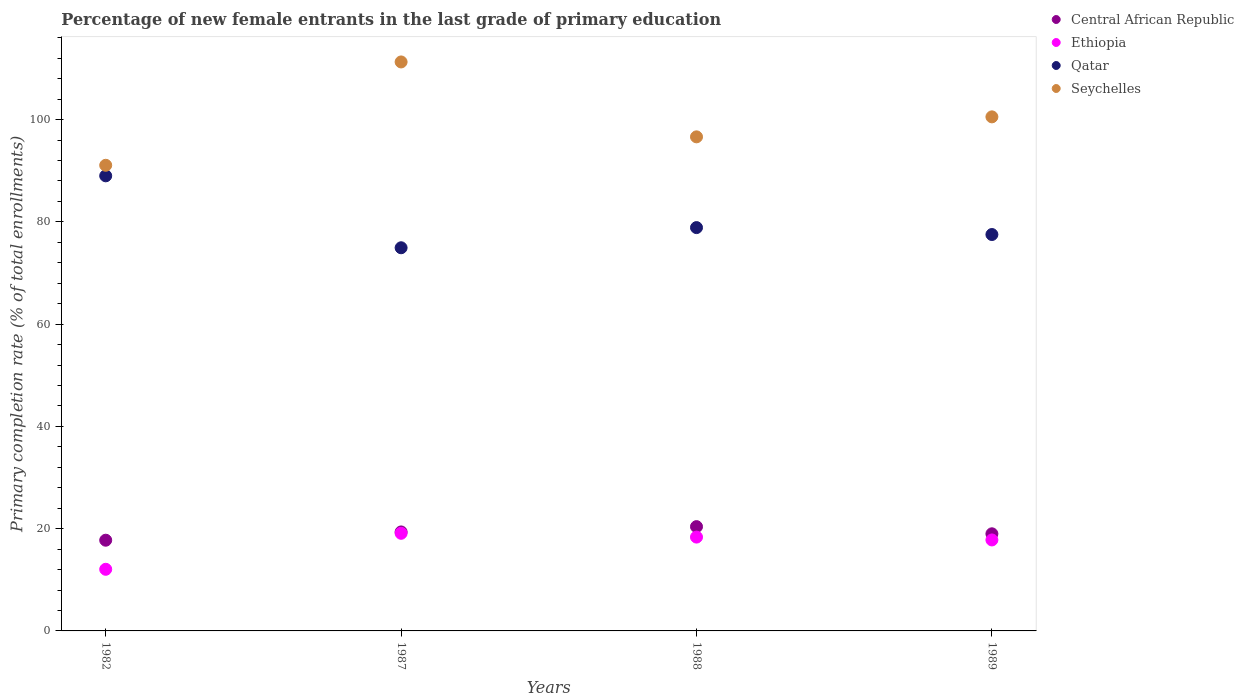How many different coloured dotlines are there?
Give a very brief answer. 4. What is the percentage of new female entrants in Central African Republic in 1988?
Make the answer very short. 20.4. Across all years, what is the maximum percentage of new female entrants in Seychelles?
Provide a succinct answer. 111.28. Across all years, what is the minimum percentage of new female entrants in Seychelles?
Your answer should be compact. 91.06. What is the total percentage of new female entrants in Ethiopia in the graph?
Your answer should be very brief. 67.29. What is the difference between the percentage of new female entrants in Ethiopia in 1987 and that in 1988?
Offer a terse response. 0.74. What is the difference between the percentage of new female entrants in Seychelles in 1982 and the percentage of new female entrants in Qatar in 1987?
Your answer should be very brief. 16.13. What is the average percentage of new female entrants in Qatar per year?
Your response must be concise. 80.08. In the year 1988, what is the difference between the percentage of new female entrants in Seychelles and percentage of new female entrants in Ethiopia?
Offer a very short reply. 78.28. In how many years, is the percentage of new female entrants in Seychelles greater than 8 %?
Give a very brief answer. 4. What is the ratio of the percentage of new female entrants in Ethiopia in 1988 to that in 1989?
Ensure brevity in your answer.  1.03. What is the difference between the highest and the second highest percentage of new female entrants in Central African Republic?
Give a very brief answer. 1.03. What is the difference between the highest and the lowest percentage of new female entrants in Qatar?
Keep it short and to the point. 14.07. In how many years, is the percentage of new female entrants in Seychelles greater than the average percentage of new female entrants in Seychelles taken over all years?
Your answer should be very brief. 2. Is the sum of the percentage of new female entrants in Seychelles in 1982 and 1987 greater than the maximum percentage of new female entrants in Qatar across all years?
Keep it short and to the point. Yes. What is the difference between two consecutive major ticks on the Y-axis?
Make the answer very short. 20. Does the graph contain any zero values?
Provide a succinct answer. No. Does the graph contain grids?
Ensure brevity in your answer.  No. Where does the legend appear in the graph?
Give a very brief answer. Top right. How are the legend labels stacked?
Provide a succinct answer. Vertical. What is the title of the graph?
Ensure brevity in your answer.  Percentage of new female entrants in the last grade of primary education. Does "Turkey" appear as one of the legend labels in the graph?
Keep it short and to the point. No. What is the label or title of the Y-axis?
Provide a short and direct response. Primary completion rate (% of total enrollments). What is the Primary completion rate (% of total enrollments) of Central African Republic in 1982?
Provide a succinct answer. 17.74. What is the Primary completion rate (% of total enrollments) in Ethiopia in 1982?
Your answer should be very brief. 12.05. What is the Primary completion rate (% of total enrollments) in Qatar in 1982?
Your answer should be compact. 89. What is the Primary completion rate (% of total enrollments) in Seychelles in 1982?
Keep it short and to the point. 91.06. What is the Primary completion rate (% of total enrollments) of Central African Republic in 1987?
Provide a short and direct response. 19.36. What is the Primary completion rate (% of total enrollments) in Ethiopia in 1987?
Your response must be concise. 19.09. What is the Primary completion rate (% of total enrollments) in Qatar in 1987?
Offer a terse response. 74.93. What is the Primary completion rate (% of total enrollments) of Seychelles in 1987?
Offer a very short reply. 111.28. What is the Primary completion rate (% of total enrollments) of Central African Republic in 1988?
Your answer should be compact. 20.4. What is the Primary completion rate (% of total enrollments) in Ethiopia in 1988?
Your answer should be very brief. 18.35. What is the Primary completion rate (% of total enrollments) of Qatar in 1988?
Ensure brevity in your answer.  78.88. What is the Primary completion rate (% of total enrollments) in Seychelles in 1988?
Your answer should be compact. 96.63. What is the Primary completion rate (% of total enrollments) of Central African Republic in 1989?
Offer a very short reply. 18.99. What is the Primary completion rate (% of total enrollments) of Ethiopia in 1989?
Make the answer very short. 17.79. What is the Primary completion rate (% of total enrollments) of Qatar in 1989?
Your response must be concise. 77.52. What is the Primary completion rate (% of total enrollments) in Seychelles in 1989?
Your answer should be compact. 100.53. Across all years, what is the maximum Primary completion rate (% of total enrollments) in Central African Republic?
Ensure brevity in your answer.  20.4. Across all years, what is the maximum Primary completion rate (% of total enrollments) of Ethiopia?
Offer a very short reply. 19.09. Across all years, what is the maximum Primary completion rate (% of total enrollments) in Qatar?
Offer a very short reply. 89. Across all years, what is the maximum Primary completion rate (% of total enrollments) of Seychelles?
Offer a terse response. 111.28. Across all years, what is the minimum Primary completion rate (% of total enrollments) of Central African Republic?
Provide a succinct answer. 17.74. Across all years, what is the minimum Primary completion rate (% of total enrollments) in Ethiopia?
Ensure brevity in your answer.  12.05. Across all years, what is the minimum Primary completion rate (% of total enrollments) in Qatar?
Make the answer very short. 74.93. Across all years, what is the minimum Primary completion rate (% of total enrollments) in Seychelles?
Make the answer very short. 91.06. What is the total Primary completion rate (% of total enrollments) in Central African Republic in the graph?
Your response must be concise. 76.49. What is the total Primary completion rate (% of total enrollments) of Ethiopia in the graph?
Offer a very short reply. 67.29. What is the total Primary completion rate (% of total enrollments) in Qatar in the graph?
Keep it short and to the point. 320.34. What is the total Primary completion rate (% of total enrollments) of Seychelles in the graph?
Your answer should be very brief. 399.5. What is the difference between the Primary completion rate (% of total enrollments) of Central African Republic in 1982 and that in 1987?
Offer a terse response. -1.62. What is the difference between the Primary completion rate (% of total enrollments) of Ethiopia in 1982 and that in 1987?
Keep it short and to the point. -7.04. What is the difference between the Primary completion rate (% of total enrollments) of Qatar in 1982 and that in 1987?
Your response must be concise. 14.07. What is the difference between the Primary completion rate (% of total enrollments) in Seychelles in 1982 and that in 1987?
Your response must be concise. -20.21. What is the difference between the Primary completion rate (% of total enrollments) of Central African Republic in 1982 and that in 1988?
Offer a very short reply. -2.65. What is the difference between the Primary completion rate (% of total enrollments) of Ethiopia in 1982 and that in 1988?
Provide a short and direct response. -6.3. What is the difference between the Primary completion rate (% of total enrollments) of Qatar in 1982 and that in 1988?
Offer a terse response. 10.12. What is the difference between the Primary completion rate (% of total enrollments) of Seychelles in 1982 and that in 1988?
Your answer should be compact. -5.56. What is the difference between the Primary completion rate (% of total enrollments) in Central African Republic in 1982 and that in 1989?
Offer a terse response. -1.25. What is the difference between the Primary completion rate (% of total enrollments) of Ethiopia in 1982 and that in 1989?
Give a very brief answer. -5.74. What is the difference between the Primary completion rate (% of total enrollments) in Qatar in 1982 and that in 1989?
Your answer should be very brief. 11.48. What is the difference between the Primary completion rate (% of total enrollments) in Seychelles in 1982 and that in 1989?
Offer a terse response. -9.47. What is the difference between the Primary completion rate (% of total enrollments) in Central African Republic in 1987 and that in 1988?
Make the answer very short. -1.03. What is the difference between the Primary completion rate (% of total enrollments) in Ethiopia in 1987 and that in 1988?
Offer a very short reply. 0.74. What is the difference between the Primary completion rate (% of total enrollments) in Qatar in 1987 and that in 1988?
Ensure brevity in your answer.  -3.94. What is the difference between the Primary completion rate (% of total enrollments) of Seychelles in 1987 and that in 1988?
Provide a short and direct response. 14.65. What is the difference between the Primary completion rate (% of total enrollments) in Central African Republic in 1987 and that in 1989?
Provide a succinct answer. 0.37. What is the difference between the Primary completion rate (% of total enrollments) in Ethiopia in 1987 and that in 1989?
Provide a short and direct response. 1.3. What is the difference between the Primary completion rate (% of total enrollments) of Qatar in 1987 and that in 1989?
Your answer should be very brief. -2.59. What is the difference between the Primary completion rate (% of total enrollments) of Seychelles in 1987 and that in 1989?
Keep it short and to the point. 10.74. What is the difference between the Primary completion rate (% of total enrollments) of Central African Republic in 1988 and that in 1989?
Provide a succinct answer. 1.4. What is the difference between the Primary completion rate (% of total enrollments) of Ethiopia in 1988 and that in 1989?
Your answer should be compact. 0.56. What is the difference between the Primary completion rate (% of total enrollments) of Qatar in 1988 and that in 1989?
Your answer should be very brief. 1.35. What is the difference between the Primary completion rate (% of total enrollments) in Seychelles in 1988 and that in 1989?
Offer a very short reply. -3.91. What is the difference between the Primary completion rate (% of total enrollments) in Central African Republic in 1982 and the Primary completion rate (% of total enrollments) in Ethiopia in 1987?
Your response must be concise. -1.35. What is the difference between the Primary completion rate (% of total enrollments) in Central African Republic in 1982 and the Primary completion rate (% of total enrollments) in Qatar in 1987?
Ensure brevity in your answer.  -57.19. What is the difference between the Primary completion rate (% of total enrollments) in Central African Republic in 1982 and the Primary completion rate (% of total enrollments) in Seychelles in 1987?
Provide a succinct answer. -93.53. What is the difference between the Primary completion rate (% of total enrollments) of Ethiopia in 1982 and the Primary completion rate (% of total enrollments) of Qatar in 1987?
Provide a short and direct response. -62.88. What is the difference between the Primary completion rate (% of total enrollments) in Ethiopia in 1982 and the Primary completion rate (% of total enrollments) in Seychelles in 1987?
Give a very brief answer. -99.22. What is the difference between the Primary completion rate (% of total enrollments) of Qatar in 1982 and the Primary completion rate (% of total enrollments) of Seychelles in 1987?
Keep it short and to the point. -22.27. What is the difference between the Primary completion rate (% of total enrollments) in Central African Republic in 1982 and the Primary completion rate (% of total enrollments) in Ethiopia in 1988?
Ensure brevity in your answer.  -0.61. What is the difference between the Primary completion rate (% of total enrollments) of Central African Republic in 1982 and the Primary completion rate (% of total enrollments) of Qatar in 1988?
Provide a short and direct response. -61.14. What is the difference between the Primary completion rate (% of total enrollments) in Central African Republic in 1982 and the Primary completion rate (% of total enrollments) in Seychelles in 1988?
Provide a succinct answer. -78.89. What is the difference between the Primary completion rate (% of total enrollments) of Ethiopia in 1982 and the Primary completion rate (% of total enrollments) of Qatar in 1988?
Provide a short and direct response. -66.82. What is the difference between the Primary completion rate (% of total enrollments) of Ethiopia in 1982 and the Primary completion rate (% of total enrollments) of Seychelles in 1988?
Your answer should be compact. -84.57. What is the difference between the Primary completion rate (% of total enrollments) in Qatar in 1982 and the Primary completion rate (% of total enrollments) in Seychelles in 1988?
Keep it short and to the point. -7.62. What is the difference between the Primary completion rate (% of total enrollments) of Central African Republic in 1982 and the Primary completion rate (% of total enrollments) of Ethiopia in 1989?
Keep it short and to the point. -0.05. What is the difference between the Primary completion rate (% of total enrollments) of Central African Republic in 1982 and the Primary completion rate (% of total enrollments) of Qatar in 1989?
Your answer should be compact. -59.78. What is the difference between the Primary completion rate (% of total enrollments) in Central African Republic in 1982 and the Primary completion rate (% of total enrollments) in Seychelles in 1989?
Provide a short and direct response. -82.79. What is the difference between the Primary completion rate (% of total enrollments) in Ethiopia in 1982 and the Primary completion rate (% of total enrollments) in Qatar in 1989?
Offer a very short reply. -65.47. What is the difference between the Primary completion rate (% of total enrollments) of Ethiopia in 1982 and the Primary completion rate (% of total enrollments) of Seychelles in 1989?
Provide a short and direct response. -88.48. What is the difference between the Primary completion rate (% of total enrollments) in Qatar in 1982 and the Primary completion rate (% of total enrollments) in Seychelles in 1989?
Give a very brief answer. -11.53. What is the difference between the Primary completion rate (% of total enrollments) in Central African Republic in 1987 and the Primary completion rate (% of total enrollments) in Ethiopia in 1988?
Your answer should be very brief. 1.01. What is the difference between the Primary completion rate (% of total enrollments) of Central African Republic in 1987 and the Primary completion rate (% of total enrollments) of Qatar in 1988?
Keep it short and to the point. -59.52. What is the difference between the Primary completion rate (% of total enrollments) of Central African Republic in 1987 and the Primary completion rate (% of total enrollments) of Seychelles in 1988?
Your answer should be very brief. -77.27. What is the difference between the Primary completion rate (% of total enrollments) in Ethiopia in 1987 and the Primary completion rate (% of total enrollments) in Qatar in 1988?
Ensure brevity in your answer.  -59.79. What is the difference between the Primary completion rate (% of total enrollments) of Ethiopia in 1987 and the Primary completion rate (% of total enrollments) of Seychelles in 1988?
Provide a succinct answer. -77.54. What is the difference between the Primary completion rate (% of total enrollments) in Qatar in 1987 and the Primary completion rate (% of total enrollments) in Seychelles in 1988?
Ensure brevity in your answer.  -21.69. What is the difference between the Primary completion rate (% of total enrollments) of Central African Republic in 1987 and the Primary completion rate (% of total enrollments) of Ethiopia in 1989?
Your answer should be very brief. 1.57. What is the difference between the Primary completion rate (% of total enrollments) in Central African Republic in 1987 and the Primary completion rate (% of total enrollments) in Qatar in 1989?
Offer a very short reply. -58.16. What is the difference between the Primary completion rate (% of total enrollments) of Central African Republic in 1987 and the Primary completion rate (% of total enrollments) of Seychelles in 1989?
Your answer should be compact. -81.17. What is the difference between the Primary completion rate (% of total enrollments) in Ethiopia in 1987 and the Primary completion rate (% of total enrollments) in Qatar in 1989?
Make the answer very short. -58.43. What is the difference between the Primary completion rate (% of total enrollments) in Ethiopia in 1987 and the Primary completion rate (% of total enrollments) in Seychelles in 1989?
Keep it short and to the point. -81.44. What is the difference between the Primary completion rate (% of total enrollments) in Qatar in 1987 and the Primary completion rate (% of total enrollments) in Seychelles in 1989?
Ensure brevity in your answer.  -25.6. What is the difference between the Primary completion rate (% of total enrollments) in Central African Republic in 1988 and the Primary completion rate (% of total enrollments) in Ethiopia in 1989?
Keep it short and to the point. 2.6. What is the difference between the Primary completion rate (% of total enrollments) of Central African Republic in 1988 and the Primary completion rate (% of total enrollments) of Qatar in 1989?
Your answer should be very brief. -57.13. What is the difference between the Primary completion rate (% of total enrollments) in Central African Republic in 1988 and the Primary completion rate (% of total enrollments) in Seychelles in 1989?
Your answer should be very brief. -80.14. What is the difference between the Primary completion rate (% of total enrollments) of Ethiopia in 1988 and the Primary completion rate (% of total enrollments) of Qatar in 1989?
Provide a short and direct response. -59.17. What is the difference between the Primary completion rate (% of total enrollments) of Ethiopia in 1988 and the Primary completion rate (% of total enrollments) of Seychelles in 1989?
Make the answer very short. -82.18. What is the difference between the Primary completion rate (% of total enrollments) in Qatar in 1988 and the Primary completion rate (% of total enrollments) in Seychelles in 1989?
Your response must be concise. -21.66. What is the average Primary completion rate (% of total enrollments) of Central African Republic per year?
Provide a short and direct response. 19.12. What is the average Primary completion rate (% of total enrollments) of Ethiopia per year?
Make the answer very short. 16.82. What is the average Primary completion rate (% of total enrollments) of Qatar per year?
Provide a short and direct response. 80.08. What is the average Primary completion rate (% of total enrollments) of Seychelles per year?
Your response must be concise. 99.88. In the year 1982, what is the difference between the Primary completion rate (% of total enrollments) of Central African Republic and Primary completion rate (% of total enrollments) of Ethiopia?
Keep it short and to the point. 5.69. In the year 1982, what is the difference between the Primary completion rate (% of total enrollments) of Central African Republic and Primary completion rate (% of total enrollments) of Qatar?
Your answer should be very brief. -71.26. In the year 1982, what is the difference between the Primary completion rate (% of total enrollments) in Central African Republic and Primary completion rate (% of total enrollments) in Seychelles?
Offer a very short reply. -73.32. In the year 1982, what is the difference between the Primary completion rate (% of total enrollments) of Ethiopia and Primary completion rate (% of total enrollments) of Qatar?
Provide a short and direct response. -76.95. In the year 1982, what is the difference between the Primary completion rate (% of total enrollments) of Ethiopia and Primary completion rate (% of total enrollments) of Seychelles?
Make the answer very short. -79.01. In the year 1982, what is the difference between the Primary completion rate (% of total enrollments) of Qatar and Primary completion rate (% of total enrollments) of Seychelles?
Your response must be concise. -2.06. In the year 1987, what is the difference between the Primary completion rate (% of total enrollments) in Central African Republic and Primary completion rate (% of total enrollments) in Ethiopia?
Your answer should be compact. 0.27. In the year 1987, what is the difference between the Primary completion rate (% of total enrollments) of Central African Republic and Primary completion rate (% of total enrollments) of Qatar?
Your response must be concise. -55.57. In the year 1987, what is the difference between the Primary completion rate (% of total enrollments) in Central African Republic and Primary completion rate (% of total enrollments) in Seychelles?
Provide a succinct answer. -91.91. In the year 1987, what is the difference between the Primary completion rate (% of total enrollments) of Ethiopia and Primary completion rate (% of total enrollments) of Qatar?
Offer a very short reply. -55.84. In the year 1987, what is the difference between the Primary completion rate (% of total enrollments) of Ethiopia and Primary completion rate (% of total enrollments) of Seychelles?
Provide a succinct answer. -92.18. In the year 1987, what is the difference between the Primary completion rate (% of total enrollments) of Qatar and Primary completion rate (% of total enrollments) of Seychelles?
Your answer should be very brief. -36.34. In the year 1988, what is the difference between the Primary completion rate (% of total enrollments) in Central African Republic and Primary completion rate (% of total enrollments) in Ethiopia?
Your response must be concise. 2.05. In the year 1988, what is the difference between the Primary completion rate (% of total enrollments) in Central African Republic and Primary completion rate (% of total enrollments) in Qatar?
Your answer should be compact. -58.48. In the year 1988, what is the difference between the Primary completion rate (% of total enrollments) in Central African Republic and Primary completion rate (% of total enrollments) in Seychelles?
Provide a short and direct response. -76.23. In the year 1988, what is the difference between the Primary completion rate (% of total enrollments) of Ethiopia and Primary completion rate (% of total enrollments) of Qatar?
Give a very brief answer. -60.53. In the year 1988, what is the difference between the Primary completion rate (% of total enrollments) in Ethiopia and Primary completion rate (% of total enrollments) in Seychelles?
Give a very brief answer. -78.28. In the year 1988, what is the difference between the Primary completion rate (% of total enrollments) of Qatar and Primary completion rate (% of total enrollments) of Seychelles?
Your answer should be compact. -17.75. In the year 1989, what is the difference between the Primary completion rate (% of total enrollments) in Central African Republic and Primary completion rate (% of total enrollments) in Ethiopia?
Your answer should be compact. 1.2. In the year 1989, what is the difference between the Primary completion rate (% of total enrollments) of Central African Republic and Primary completion rate (% of total enrollments) of Qatar?
Offer a terse response. -58.53. In the year 1989, what is the difference between the Primary completion rate (% of total enrollments) of Central African Republic and Primary completion rate (% of total enrollments) of Seychelles?
Your answer should be very brief. -81.54. In the year 1989, what is the difference between the Primary completion rate (% of total enrollments) of Ethiopia and Primary completion rate (% of total enrollments) of Qatar?
Your answer should be very brief. -59.73. In the year 1989, what is the difference between the Primary completion rate (% of total enrollments) in Ethiopia and Primary completion rate (% of total enrollments) in Seychelles?
Ensure brevity in your answer.  -82.74. In the year 1989, what is the difference between the Primary completion rate (% of total enrollments) of Qatar and Primary completion rate (% of total enrollments) of Seychelles?
Offer a very short reply. -23.01. What is the ratio of the Primary completion rate (% of total enrollments) of Central African Republic in 1982 to that in 1987?
Give a very brief answer. 0.92. What is the ratio of the Primary completion rate (% of total enrollments) of Ethiopia in 1982 to that in 1987?
Your response must be concise. 0.63. What is the ratio of the Primary completion rate (% of total enrollments) of Qatar in 1982 to that in 1987?
Your answer should be very brief. 1.19. What is the ratio of the Primary completion rate (% of total enrollments) in Seychelles in 1982 to that in 1987?
Provide a short and direct response. 0.82. What is the ratio of the Primary completion rate (% of total enrollments) of Central African Republic in 1982 to that in 1988?
Offer a terse response. 0.87. What is the ratio of the Primary completion rate (% of total enrollments) in Ethiopia in 1982 to that in 1988?
Give a very brief answer. 0.66. What is the ratio of the Primary completion rate (% of total enrollments) of Qatar in 1982 to that in 1988?
Offer a very short reply. 1.13. What is the ratio of the Primary completion rate (% of total enrollments) of Seychelles in 1982 to that in 1988?
Your answer should be compact. 0.94. What is the ratio of the Primary completion rate (% of total enrollments) of Central African Republic in 1982 to that in 1989?
Ensure brevity in your answer.  0.93. What is the ratio of the Primary completion rate (% of total enrollments) in Ethiopia in 1982 to that in 1989?
Make the answer very short. 0.68. What is the ratio of the Primary completion rate (% of total enrollments) of Qatar in 1982 to that in 1989?
Provide a succinct answer. 1.15. What is the ratio of the Primary completion rate (% of total enrollments) in Seychelles in 1982 to that in 1989?
Provide a succinct answer. 0.91. What is the ratio of the Primary completion rate (% of total enrollments) of Central African Republic in 1987 to that in 1988?
Make the answer very short. 0.95. What is the ratio of the Primary completion rate (% of total enrollments) of Ethiopia in 1987 to that in 1988?
Provide a short and direct response. 1.04. What is the ratio of the Primary completion rate (% of total enrollments) in Seychelles in 1987 to that in 1988?
Offer a very short reply. 1.15. What is the ratio of the Primary completion rate (% of total enrollments) of Central African Republic in 1987 to that in 1989?
Offer a terse response. 1.02. What is the ratio of the Primary completion rate (% of total enrollments) in Ethiopia in 1987 to that in 1989?
Provide a short and direct response. 1.07. What is the ratio of the Primary completion rate (% of total enrollments) in Qatar in 1987 to that in 1989?
Give a very brief answer. 0.97. What is the ratio of the Primary completion rate (% of total enrollments) in Seychelles in 1987 to that in 1989?
Make the answer very short. 1.11. What is the ratio of the Primary completion rate (% of total enrollments) of Central African Republic in 1988 to that in 1989?
Make the answer very short. 1.07. What is the ratio of the Primary completion rate (% of total enrollments) in Ethiopia in 1988 to that in 1989?
Your response must be concise. 1.03. What is the ratio of the Primary completion rate (% of total enrollments) in Qatar in 1988 to that in 1989?
Ensure brevity in your answer.  1.02. What is the ratio of the Primary completion rate (% of total enrollments) in Seychelles in 1988 to that in 1989?
Your answer should be very brief. 0.96. What is the difference between the highest and the second highest Primary completion rate (% of total enrollments) of Central African Republic?
Offer a very short reply. 1.03. What is the difference between the highest and the second highest Primary completion rate (% of total enrollments) in Ethiopia?
Your answer should be very brief. 0.74. What is the difference between the highest and the second highest Primary completion rate (% of total enrollments) in Qatar?
Your answer should be compact. 10.12. What is the difference between the highest and the second highest Primary completion rate (% of total enrollments) of Seychelles?
Keep it short and to the point. 10.74. What is the difference between the highest and the lowest Primary completion rate (% of total enrollments) of Central African Republic?
Your response must be concise. 2.65. What is the difference between the highest and the lowest Primary completion rate (% of total enrollments) in Ethiopia?
Your answer should be very brief. 7.04. What is the difference between the highest and the lowest Primary completion rate (% of total enrollments) of Qatar?
Ensure brevity in your answer.  14.07. What is the difference between the highest and the lowest Primary completion rate (% of total enrollments) in Seychelles?
Keep it short and to the point. 20.21. 